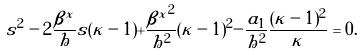Convert formula to latex. <formula><loc_0><loc_0><loc_500><loc_500>s ^ { 2 } - 2 \frac { \beta ^ { x } } { h } s ( \kappa - 1 ) + \frac { { \beta ^ { x } } ^ { 2 } } { h ^ { 2 } } ( \kappa - 1 ) ^ { 2 } - \frac { a _ { 1 } } { h ^ { 2 } } \frac { ( \kappa - 1 ) ^ { 2 } } { \kappa } = 0 .</formula> 